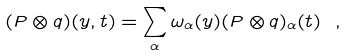<formula> <loc_0><loc_0><loc_500><loc_500>( P \otimes q ) ( y , t ) = \sum _ { \alpha } \omega _ { \alpha } ( y ) ( P \otimes q ) _ { \alpha } ( t ) \ ,</formula> 